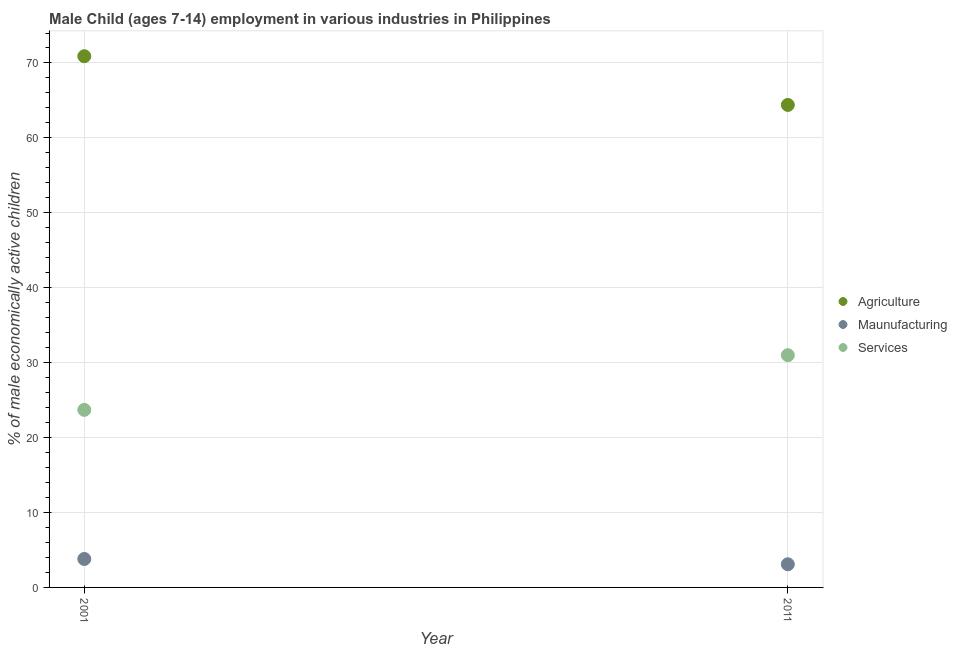What is the percentage of economically active children in manufacturing in 2001?
Provide a succinct answer. 3.8. Across all years, what is the maximum percentage of economically active children in services?
Your answer should be very brief. 31. Across all years, what is the minimum percentage of economically active children in manufacturing?
Your answer should be compact. 3.09. In which year was the percentage of economically active children in manufacturing maximum?
Your response must be concise. 2001. In which year was the percentage of economically active children in services minimum?
Keep it short and to the point. 2001. What is the total percentage of economically active children in manufacturing in the graph?
Ensure brevity in your answer.  6.89. What is the difference between the percentage of economically active children in agriculture in 2001 and that in 2011?
Provide a succinct answer. 6.5. What is the difference between the percentage of economically active children in manufacturing in 2011 and the percentage of economically active children in agriculture in 2001?
Provide a succinct answer. -67.81. What is the average percentage of economically active children in manufacturing per year?
Give a very brief answer. 3.44. In the year 2001, what is the difference between the percentage of economically active children in manufacturing and percentage of economically active children in agriculture?
Ensure brevity in your answer.  -67.1. In how many years, is the percentage of economically active children in services greater than 28 %?
Make the answer very short. 1. What is the ratio of the percentage of economically active children in manufacturing in 2001 to that in 2011?
Your answer should be compact. 1.23. Is the percentage of economically active children in agriculture in 2001 less than that in 2011?
Give a very brief answer. No. In how many years, is the percentage of economically active children in services greater than the average percentage of economically active children in services taken over all years?
Your answer should be compact. 1. Is it the case that in every year, the sum of the percentage of economically active children in agriculture and percentage of economically active children in manufacturing is greater than the percentage of economically active children in services?
Your answer should be very brief. Yes. Does the percentage of economically active children in manufacturing monotonically increase over the years?
Your response must be concise. No. Are the values on the major ticks of Y-axis written in scientific E-notation?
Provide a succinct answer. No. Does the graph contain any zero values?
Offer a very short reply. No. Does the graph contain grids?
Your answer should be very brief. Yes. Where does the legend appear in the graph?
Provide a succinct answer. Center right. How many legend labels are there?
Keep it short and to the point. 3. What is the title of the graph?
Ensure brevity in your answer.  Male Child (ages 7-14) employment in various industries in Philippines. Does "Labor Market" appear as one of the legend labels in the graph?
Your answer should be compact. No. What is the label or title of the X-axis?
Offer a terse response. Year. What is the label or title of the Y-axis?
Your answer should be very brief. % of male economically active children. What is the % of male economically active children in Agriculture in 2001?
Offer a very short reply. 70.9. What is the % of male economically active children in Maunufacturing in 2001?
Your answer should be very brief. 3.8. What is the % of male economically active children in Services in 2001?
Your answer should be compact. 23.7. What is the % of male economically active children of Agriculture in 2011?
Make the answer very short. 64.4. What is the % of male economically active children of Maunufacturing in 2011?
Your answer should be compact. 3.09. What is the % of male economically active children of Services in 2011?
Give a very brief answer. 31. Across all years, what is the maximum % of male economically active children in Agriculture?
Keep it short and to the point. 70.9. Across all years, what is the maximum % of male economically active children in Services?
Make the answer very short. 31. Across all years, what is the minimum % of male economically active children in Agriculture?
Your response must be concise. 64.4. Across all years, what is the minimum % of male economically active children of Maunufacturing?
Provide a succinct answer. 3.09. Across all years, what is the minimum % of male economically active children of Services?
Your response must be concise. 23.7. What is the total % of male economically active children in Agriculture in the graph?
Provide a succinct answer. 135.3. What is the total % of male economically active children of Maunufacturing in the graph?
Make the answer very short. 6.89. What is the total % of male economically active children in Services in the graph?
Ensure brevity in your answer.  54.7. What is the difference between the % of male economically active children in Maunufacturing in 2001 and that in 2011?
Make the answer very short. 0.71. What is the difference between the % of male economically active children of Services in 2001 and that in 2011?
Make the answer very short. -7.3. What is the difference between the % of male economically active children of Agriculture in 2001 and the % of male economically active children of Maunufacturing in 2011?
Give a very brief answer. 67.81. What is the difference between the % of male economically active children of Agriculture in 2001 and the % of male economically active children of Services in 2011?
Provide a short and direct response. 39.9. What is the difference between the % of male economically active children of Maunufacturing in 2001 and the % of male economically active children of Services in 2011?
Ensure brevity in your answer.  -27.2. What is the average % of male economically active children in Agriculture per year?
Offer a terse response. 67.65. What is the average % of male economically active children of Maunufacturing per year?
Keep it short and to the point. 3.44. What is the average % of male economically active children in Services per year?
Ensure brevity in your answer.  27.35. In the year 2001, what is the difference between the % of male economically active children in Agriculture and % of male economically active children in Maunufacturing?
Provide a succinct answer. 67.1. In the year 2001, what is the difference between the % of male economically active children of Agriculture and % of male economically active children of Services?
Keep it short and to the point. 47.2. In the year 2001, what is the difference between the % of male economically active children in Maunufacturing and % of male economically active children in Services?
Ensure brevity in your answer.  -19.9. In the year 2011, what is the difference between the % of male economically active children in Agriculture and % of male economically active children in Maunufacturing?
Provide a succinct answer. 61.31. In the year 2011, what is the difference between the % of male economically active children in Agriculture and % of male economically active children in Services?
Your response must be concise. 33.4. In the year 2011, what is the difference between the % of male economically active children of Maunufacturing and % of male economically active children of Services?
Give a very brief answer. -27.91. What is the ratio of the % of male economically active children of Agriculture in 2001 to that in 2011?
Ensure brevity in your answer.  1.1. What is the ratio of the % of male economically active children in Maunufacturing in 2001 to that in 2011?
Your response must be concise. 1.23. What is the ratio of the % of male economically active children of Services in 2001 to that in 2011?
Offer a terse response. 0.76. What is the difference between the highest and the second highest % of male economically active children in Agriculture?
Your response must be concise. 6.5. What is the difference between the highest and the second highest % of male economically active children of Maunufacturing?
Provide a succinct answer. 0.71. What is the difference between the highest and the lowest % of male economically active children in Maunufacturing?
Your answer should be compact. 0.71. 